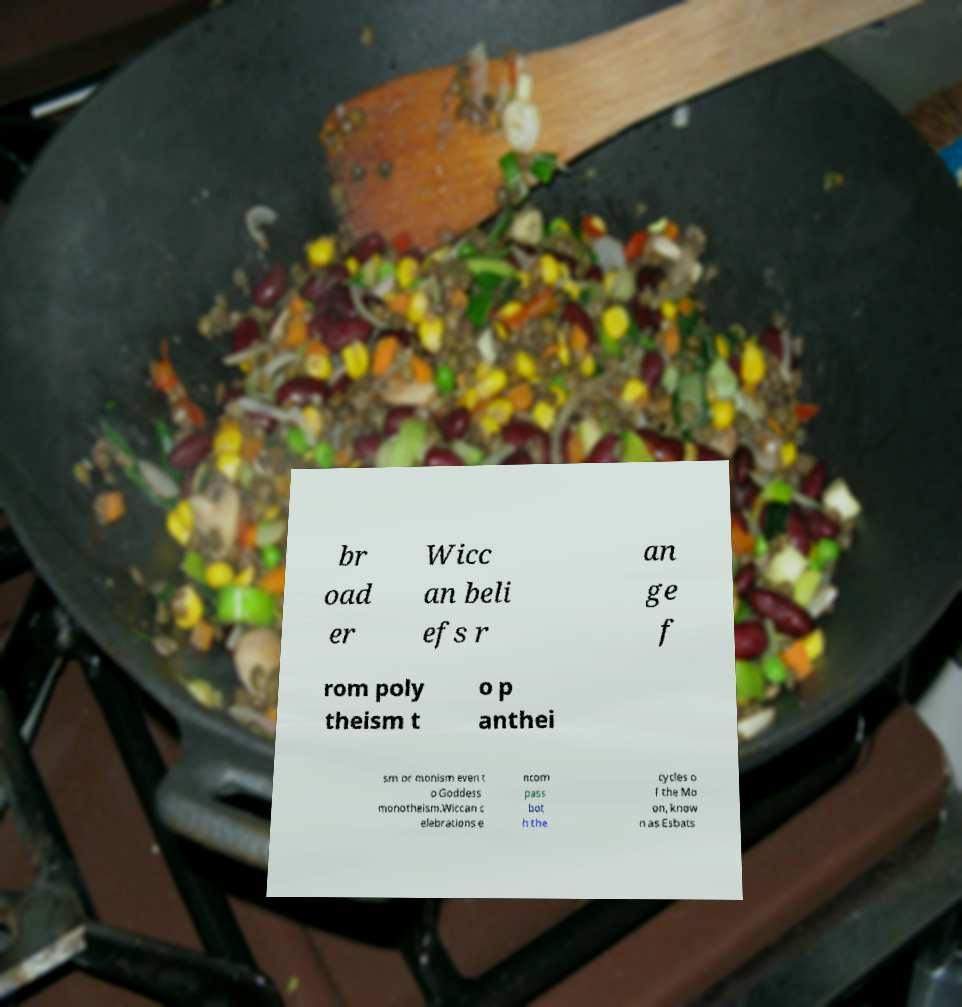Could you assist in decoding the text presented in this image and type it out clearly? br oad er Wicc an beli efs r an ge f rom poly theism t o p anthei sm or monism even t o Goddess monotheism.Wiccan c elebrations e ncom pass bot h the cycles o f the Mo on, know n as Esbats 